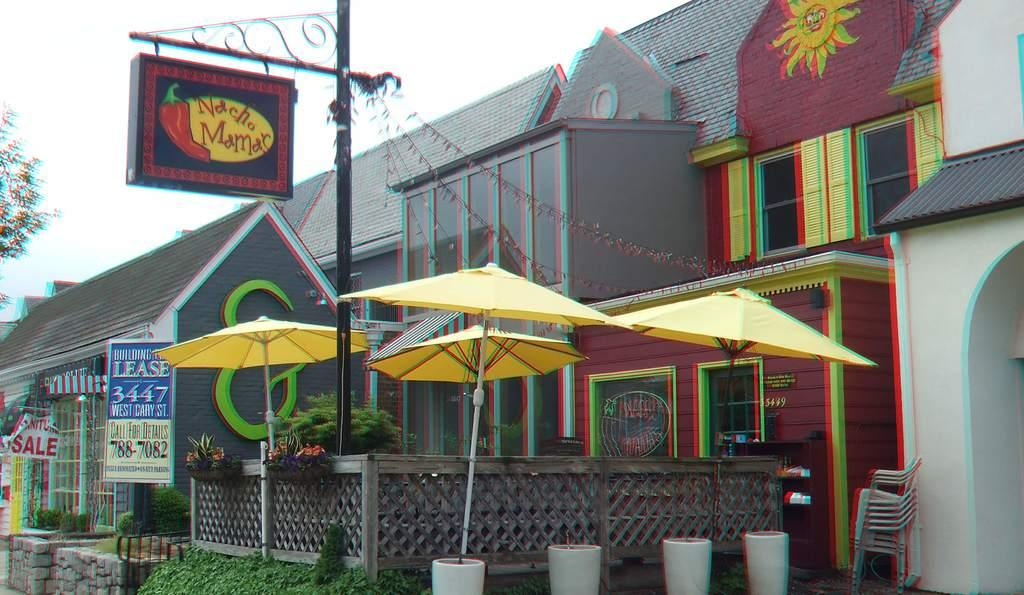What color are the umbrellas in the image? The umbrellas in the image are yellow. What type of furniture can be seen in the image? There are chairs in the image. What type of barrier is present in the image? There is a wooden fence in the image. What structure is present in the image that supports boards? There are boards attached to a pole in the image. What type of illumination is present in the image? There are lights in the image. What type of buildings can be seen in the image? There are houses in the image. What type of vegetation is present in the image? There are trees in the image. What is visible in the background of the image? The sky is visible in the background of the image. What type of crayon is being used to draw on the wooden fence in the image? There is no crayon present in the image, and therefore no drawing activity can be observed. What type of account is being discussed by the trees in the image? There are no trees discussing any accounts in the image. 